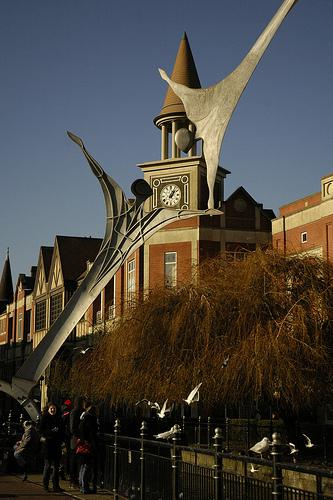Question: what color is the statue?
Choices:
A. Gray.
B. Blue.
C. Green.
D. Yellow.
Answer with the letter. Answer: A Question: what is the color of the tree?
Choices:
A. White.
B. Brown.
C. Green.
D. Speckled.
Answer with the letter. Answer: B Question: what animals are shown?
Choices:
A. Birds.
B. Cats.
C. Dogs.
D. Giraffes.
Answer with the letter. Answer: A 